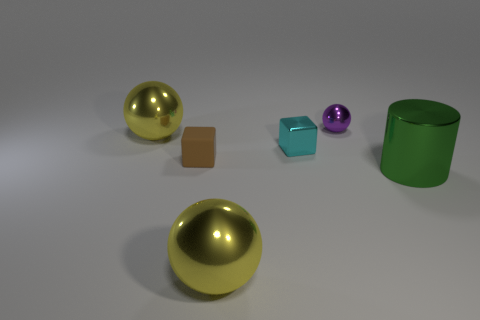Subtract all large metallic balls. How many balls are left? 1 Subtract all brown cylinders. How many yellow balls are left? 2 Subtract all cylinders. How many objects are left? 5 Add 3 tiny gray rubber cylinders. How many objects exist? 9 Subtract all cyan spheres. Subtract all gray cylinders. How many spheres are left? 3 Subtract 0 cyan cylinders. How many objects are left? 6 Subtract all shiny cylinders. Subtract all tiny objects. How many objects are left? 2 Add 4 purple balls. How many purple balls are left? 5 Add 2 small purple objects. How many small purple objects exist? 3 